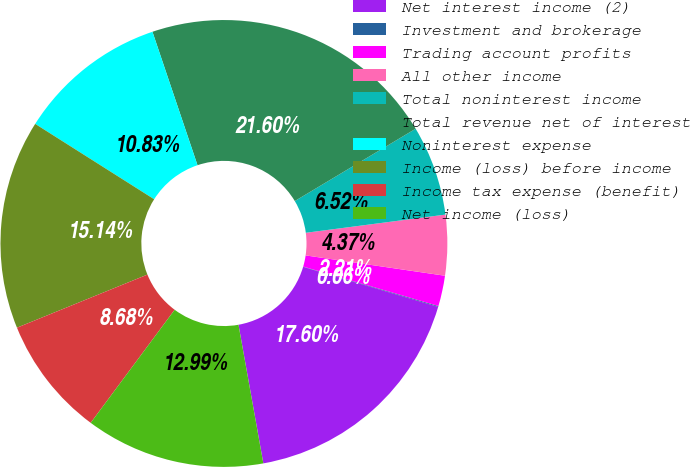<chart> <loc_0><loc_0><loc_500><loc_500><pie_chart><fcel>Net interest income (2)<fcel>Investment and brokerage<fcel>Trading account profits<fcel>All other income<fcel>Total noninterest income<fcel>Total revenue net of interest<fcel>Noninterest expense<fcel>Income (loss) before income<fcel>Income tax expense (benefit)<fcel>Net income (loss)<nl><fcel>17.6%<fcel>0.06%<fcel>2.21%<fcel>4.37%<fcel>6.52%<fcel>21.6%<fcel>10.83%<fcel>15.14%<fcel>8.68%<fcel>12.99%<nl></chart> 